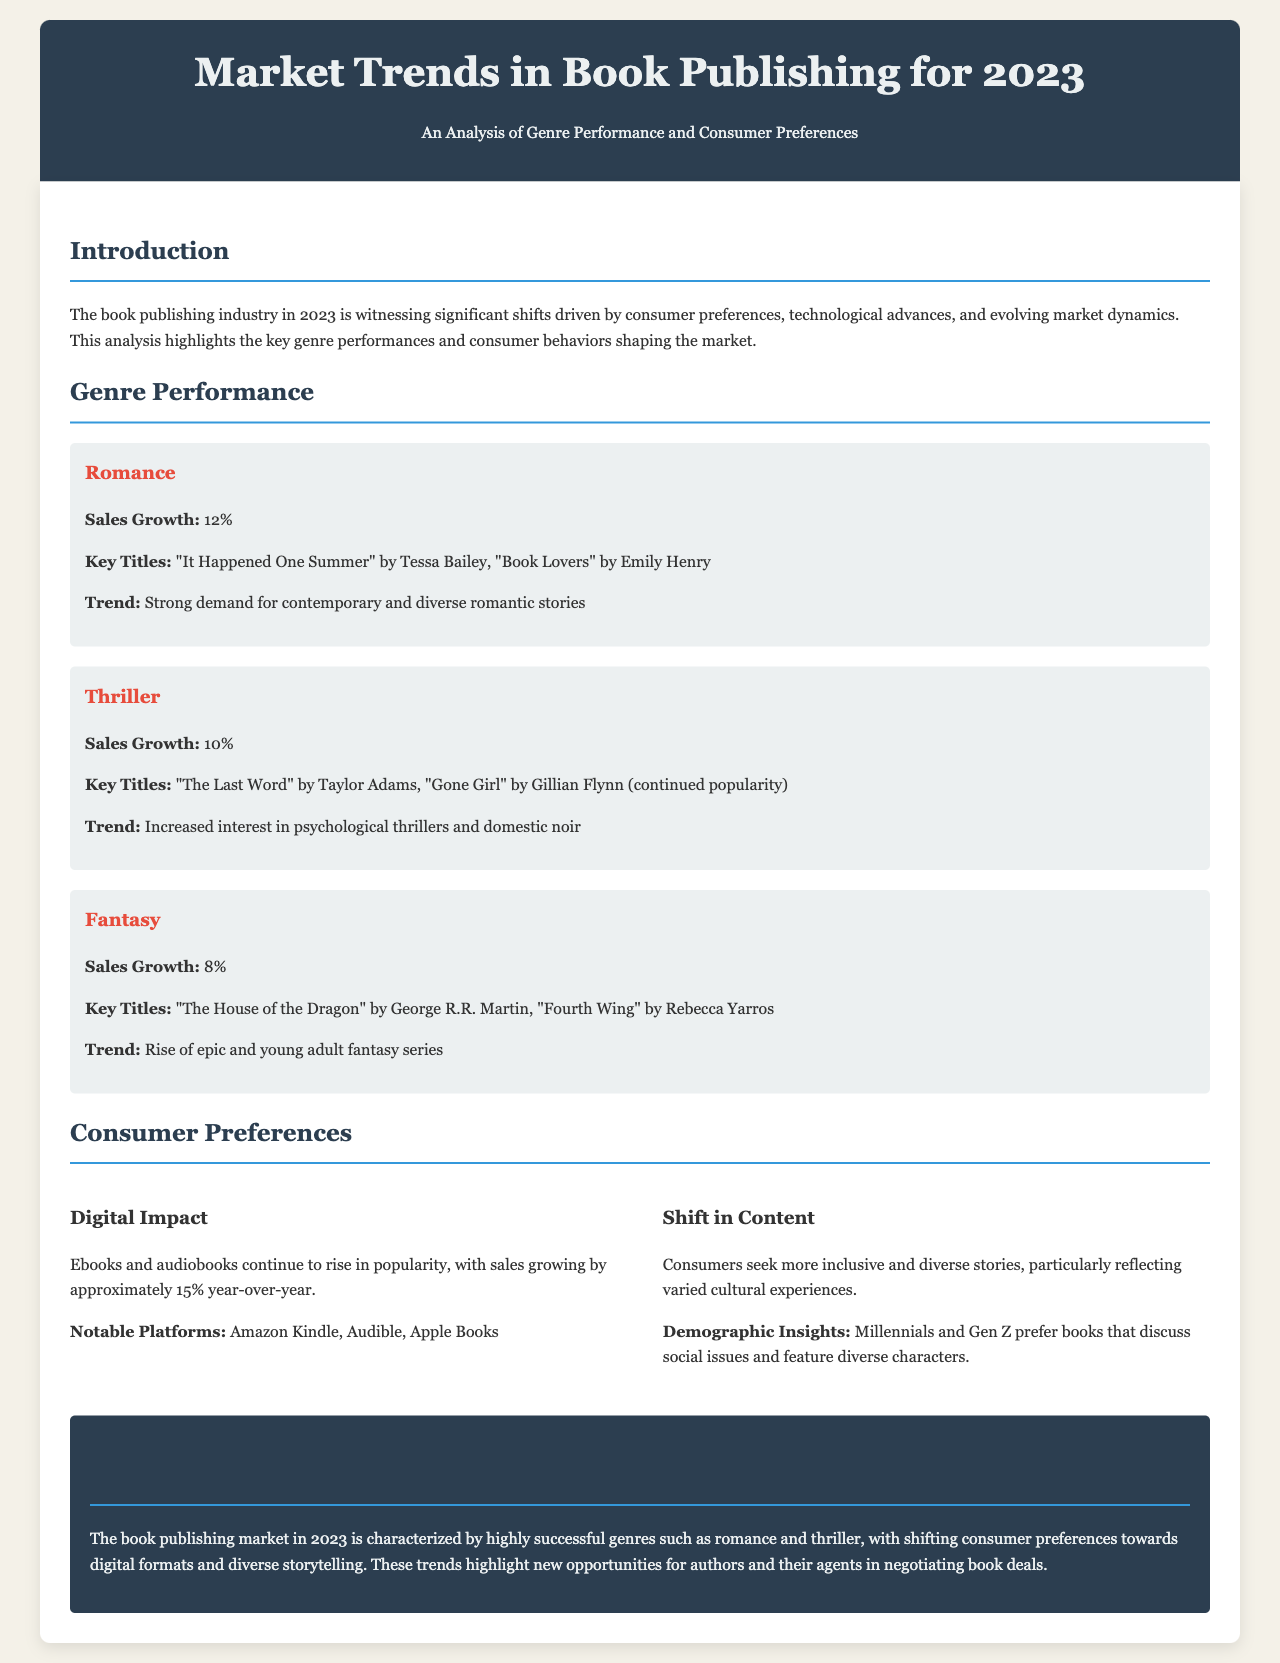what was the sales growth for the romance genre? The document states that romance experienced a sales growth of 12%.
Answer: 12% what are the key titles in the thriller genre? The document lists "The Last Word" by Taylor Adams and "Gone Girl" by Gillian Flynn as key titles for the thriller genre.
Answer: "The Last Word" by Taylor Adams, "Gone Girl" by Gillian Flynn which digital formats saw a sales growth of approximately 15%? The document mentions that ebooks and audiobooks sales grew in popularity, specifically mentioning a 15% growth.
Answer: ebooks and audiobooks who are the primary demographics seeking diverse storytelling? The document notes that Millennials and Gen Z are the primary demographics that prefer books featuring diverse characters and social issues.
Answer: Millennials and Gen Z what genre had the highest sales growth among those mentioned? Comparing the sales growth figures, romance at 12% had the highest sales growth among the genres listed.
Answer: romance what notable platforms are mentioned for digital books? The document identifies Amazon Kindle, Audible, and Apple Books as notable platforms for digital book sales.
Answer: Amazon Kindle, Audible, Apple Books what trends are noted in consumer preferences? The document highlights that consumers are seeking more inclusive and diverse stories in their reading material.
Answer: more inclusive and diverse stories how does the report characterize the current market in book publishing? The document characterizes the 2023 book publishing market with successful genres and shifting consumer preferences.
Answer: successful genres and shifting consumer preferences 